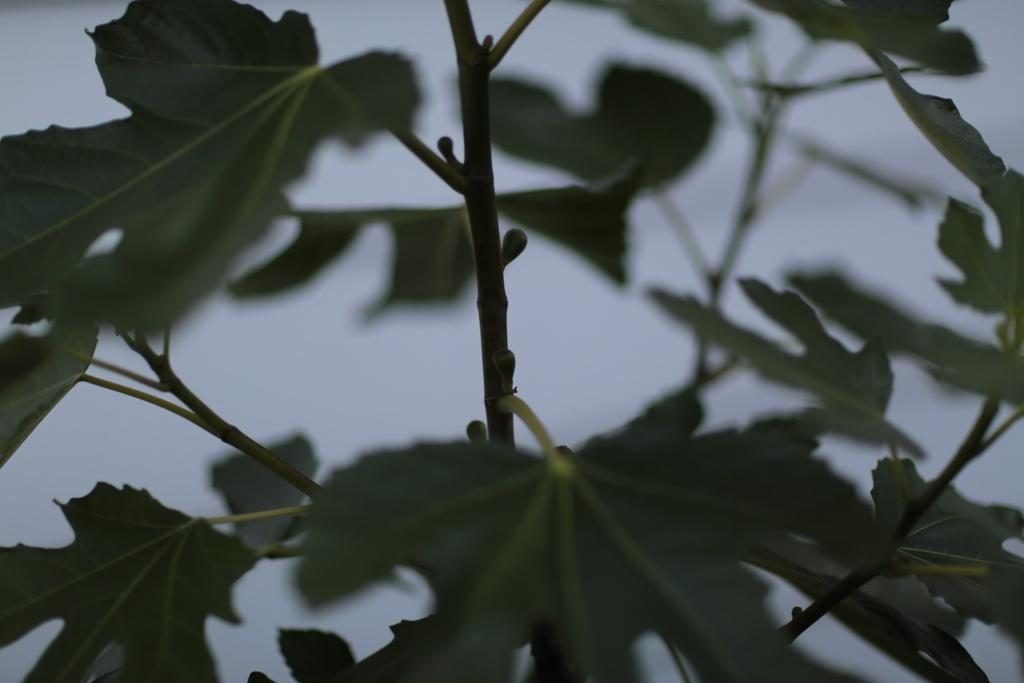What type of plant material can be seen in the image? There are leaves in the image. Can you describe any other part of the plant visible in the image? There is a stem in the image. What type of organization is responsible for the drug production in the image? There is no organization or drug production present in the image; it only features leaves and a stem. 